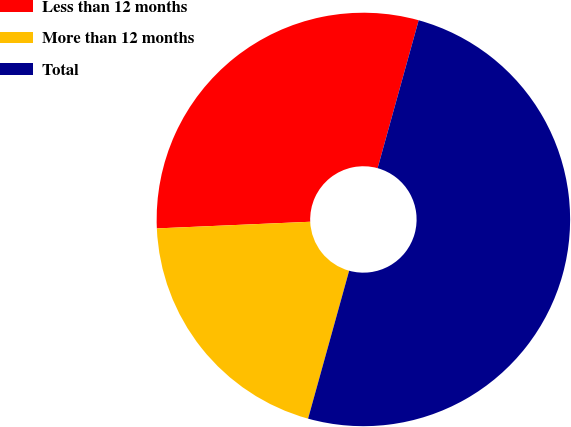<chart> <loc_0><loc_0><loc_500><loc_500><pie_chart><fcel>Less than 12 months<fcel>More than 12 months<fcel>Total<nl><fcel>30.0%<fcel>20.0%<fcel>50.0%<nl></chart> 